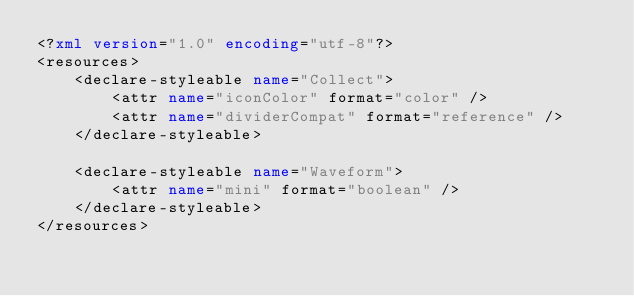Convert code to text. <code><loc_0><loc_0><loc_500><loc_500><_XML_><?xml version="1.0" encoding="utf-8"?>
<resources>
    <declare-styleable name="Collect">
        <attr name="iconColor" format="color" />
        <attr name="dividerCompat" format="reference" />
    </declare-styleable>

    <declare-styleable name="Waveform">
        <attr name="mini" format="boolean" />
    </declare-styleable>
</resources>
</code> 